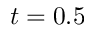Convert formula to latex. <formula><loc_0><loc_0><loc_500><loc_500>t = 0 . 5</formula> 